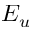<formula> <loc_0><loc_0><loc_500><loc_500>E _ { u }</formula> 